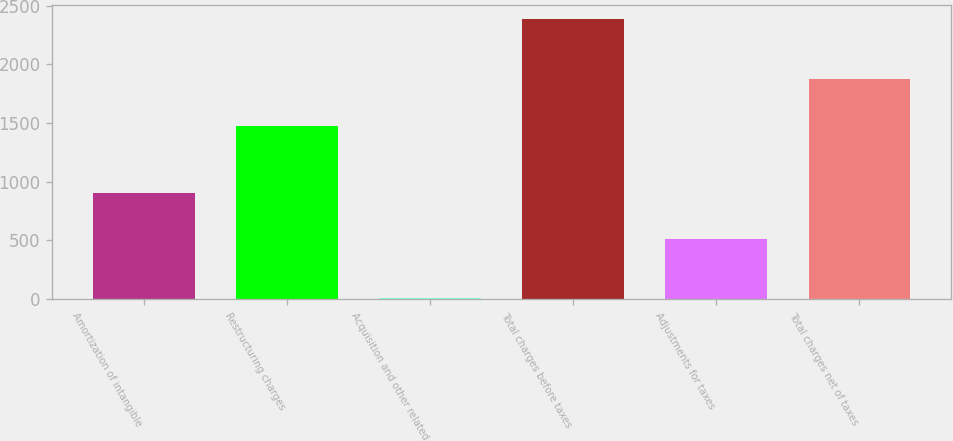Convert chart. <chart><loc_0><loc_0><loc_500><loc_500><bar_chart><fcel>Amortization of intangible<fcel>Restructuring charges<fcel>Acquisition and other related<fcel>Total charges before taxes<fcel>Adjustments for taxes<fcel>Total charges net of taxes<nl><fcel>906<fcel>1471<fcel>11<fcel>2388<fcel>510<fcel>1878<nl></chart> 